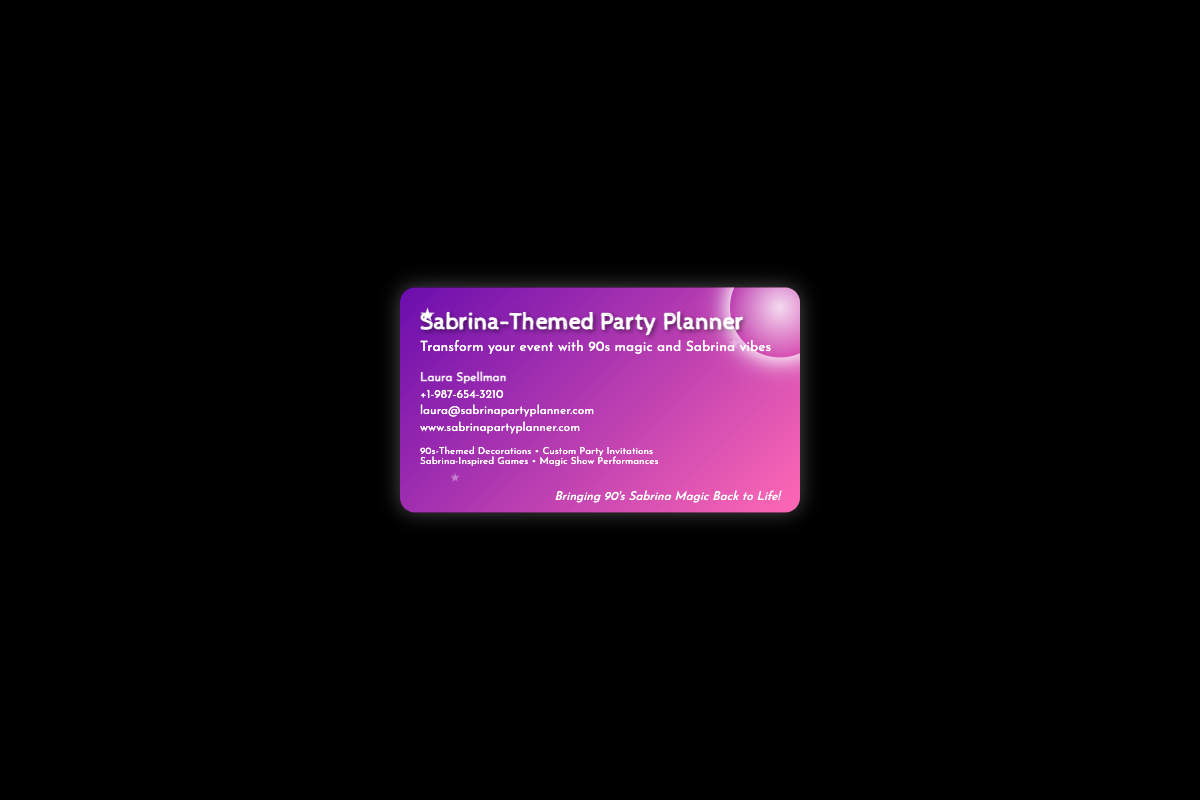What is the name of the party planner? The document states the name of the party planner as Laura Spellman.
Answer: Laura Spellman What is the contact phone number? The phone number provided in the document is +1-987-654-3210.
Answer: +1-987-654-3210 What type of events does the planner specialize in? The planner specializes in transforming events with 90s magic and Sabrina vibes, as indicated in the tagline.
Answer: 90s magic and Sabrina vibes What services are offered by the party planner? The document lists several services including 90s-Themed Decorations and Magic Show Performances.
Answer: 90s-Themed Decorations • Custom Party Invitations • Sabrina-Inspired Games • Magic Show Performances What is the tagline on the business card? The tagline at the bottom of the card is "Bringing 90's Sabrina Magic Back to Life!"
Answer: Bringing 90's Sabrina Magic Back to Life! What design elements are included in the card? The card design features a crystal ball, stars, and a colorful gradient background.
Answer: Crystal ball and stars How many stars are depicted on the business card? There are three stars shown on the business card.
Answer: Three stars What color gradient is used for the card background? The card features a gradient of purple and pink colors.
Answer: Purple and pink 